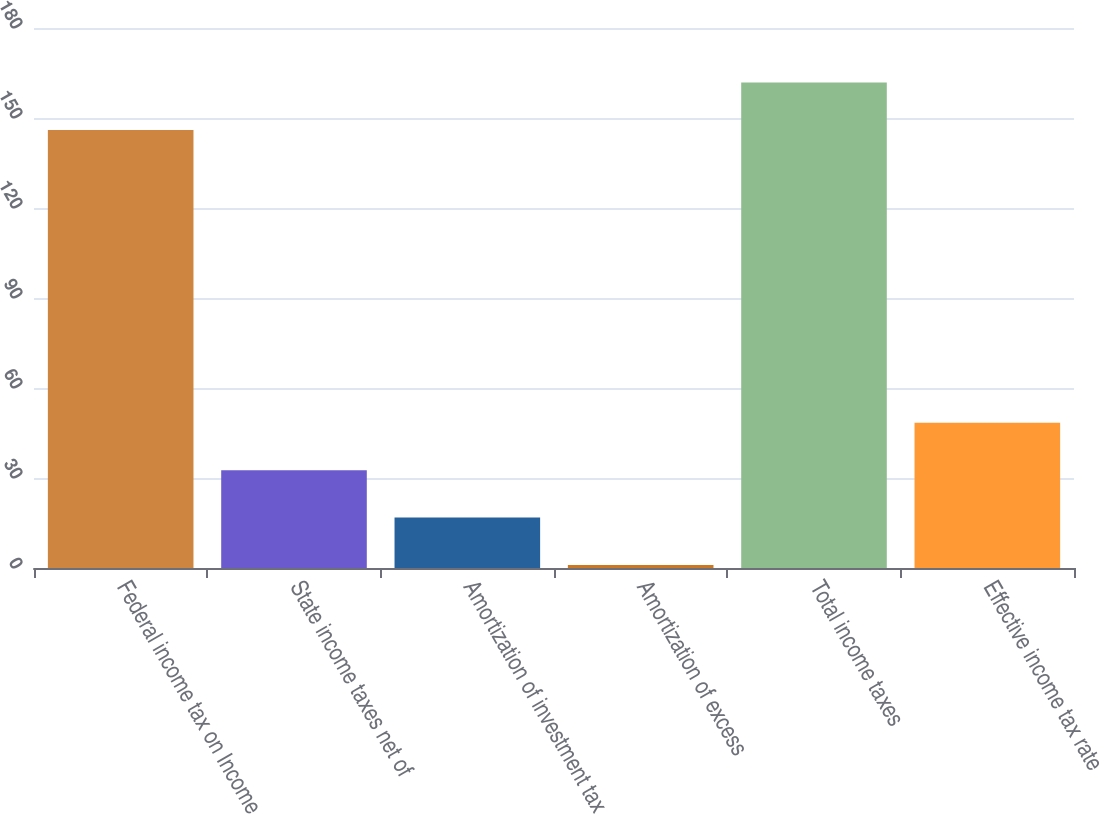Convert chart to OTSL. <chart><loc_0><loc_0><loc_500><loc_500><bar_chart><fcel>Federal income tax on Income<fcel>State income taxes net of<fcel>Amortization of investment tax<fcel>Amortization of excess<fcel>Total income taxes<fcel>Effective income tax rate<nl><fcel>146<fcel>32.6<fcel>16.8<fcel>1<fcel>161.8<fcel>48.4<nl></chart> 